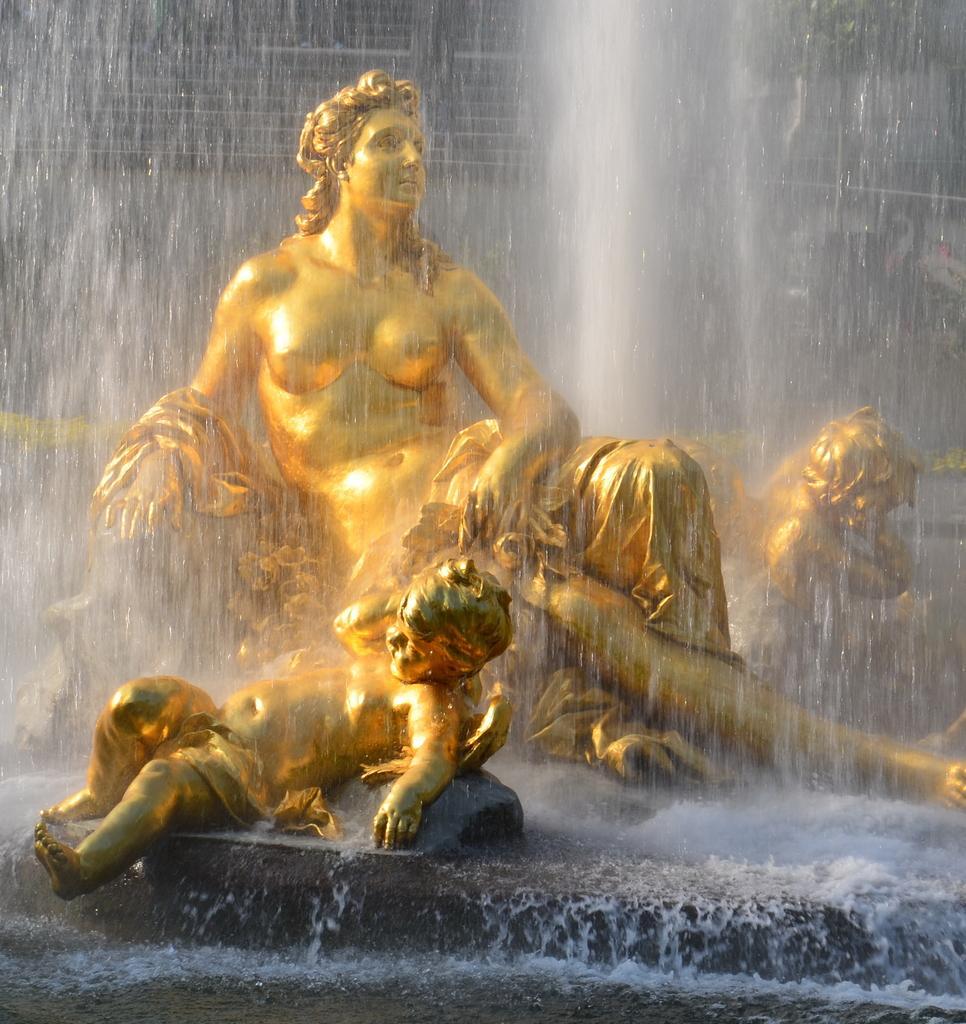Describe this image in one or two sentences. We can see water and gold color statues of people. 